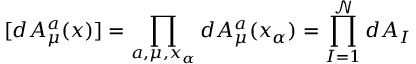<formula> <loc_0><loc_0><loc_500><loc_500>[ d A _ { \mu } ^ { a } ( x ) ] = { \prod _ { a , \mu , x _ { \alpha } } d A _ { \mu } ^ { a } ( x _ { \alpha } ) = { \prod _ { I = 1 } ^ { \mathcal { N } } d A _ { I } } }</formula> 